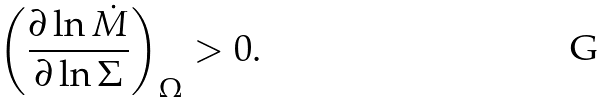Convert formula to latex. <formula><loc_0><loc_0><loc_500><loc_500>\left ( \frac { \partial \ln \dot { M } } { \partial \ln \Sigma } \right ) _ { \Omega } > 0 .</formula> 